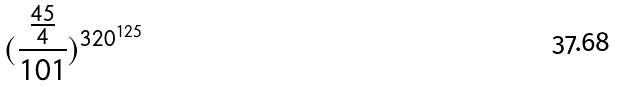Convert formula to latex. <formula><loc_0><loc_0><loc_500><loc_500>( \frac { \frac { 4 5 } { 4 } } { 1 0 1 } ) ^ { 3 2 0 ^ { 1 2 5 } }</formula> 